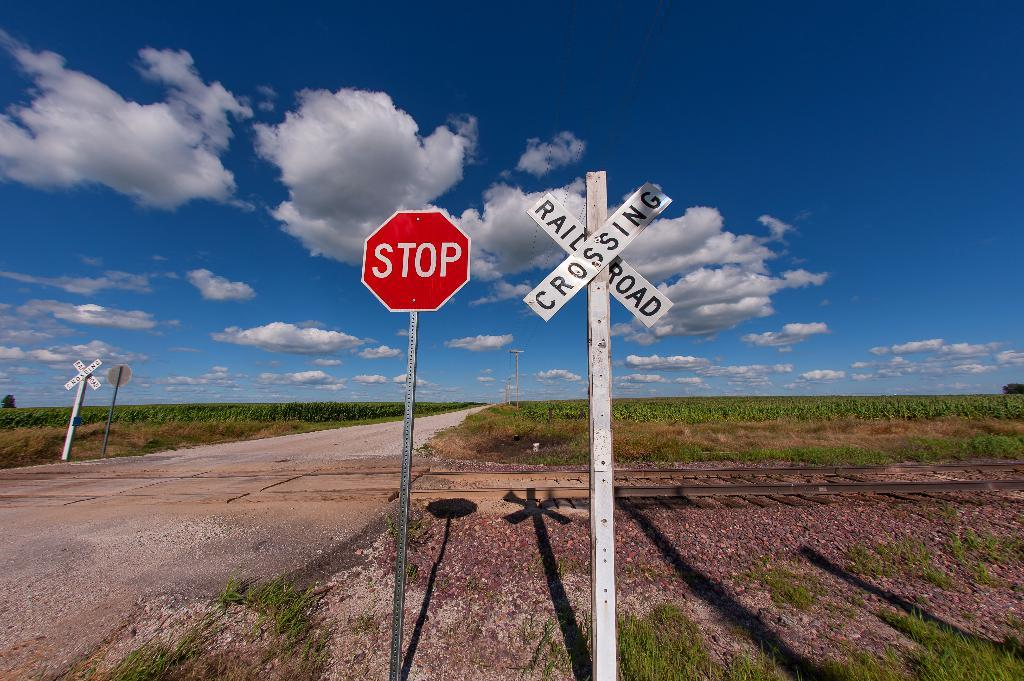<image>
Share a concise interpretation of the image provided. Stop sign next to railroad crossing on rural road. 